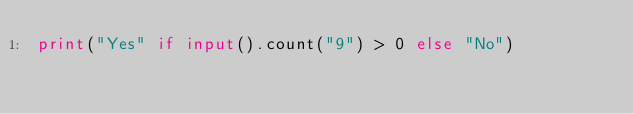<code> <loc_0><loc_0><loc_500><loc_500><_Python_>print("Yes" if input().count("9") > 0 else "No")</code> 